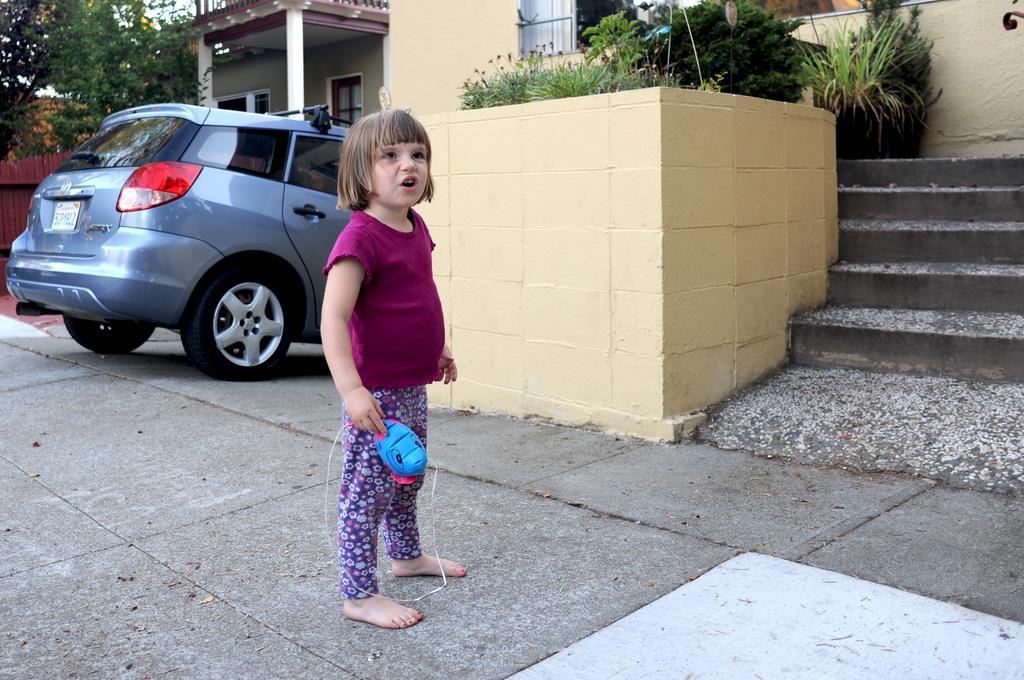How would you summarize this image in a sentence or two? In this image I see a girl who is wearing pink color top and pants and I see that she is holding a toy which is of blue and pink in color and I see the path. In the background I see a car, few plants over here, steps and I see the trees, fencing over here and I see the houses. 